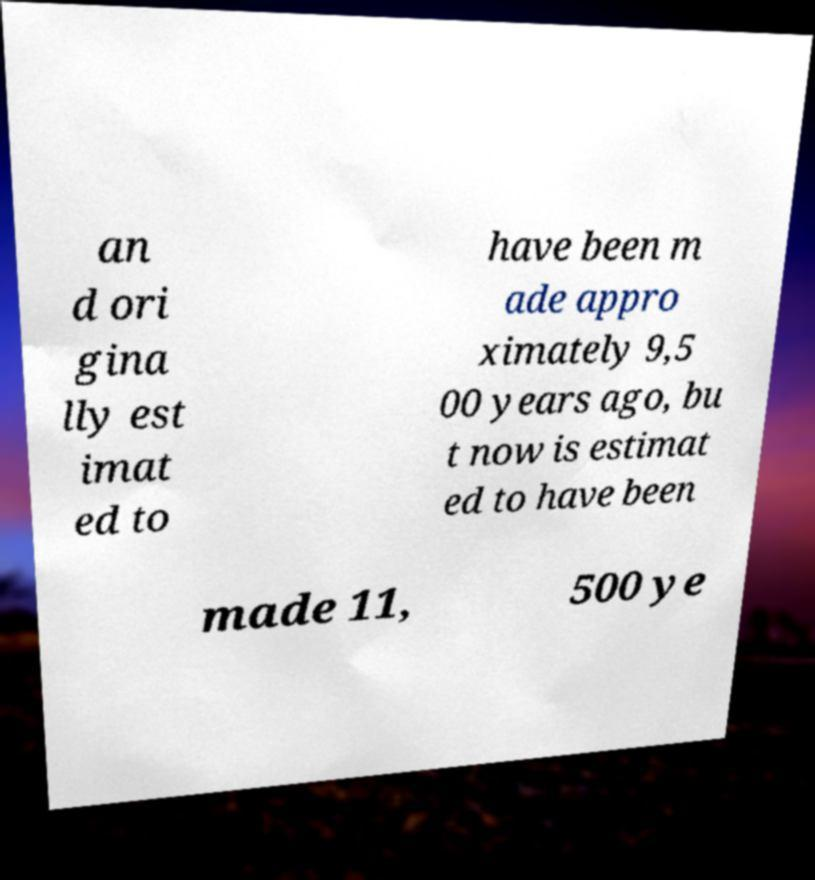For documentation purposes, I need the text within this image transcribed. Could you provide that? an d ori gina lly est imat ed to have been m ade appro ximately 9,5 00 years ago, bu t now is estimat ed to have been made 11, 500 ye 